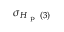<formula> <loc_0><loc_0><loc_500><loc_500>\sigma _ { H _ { p } ( 3 ) }</formula> 